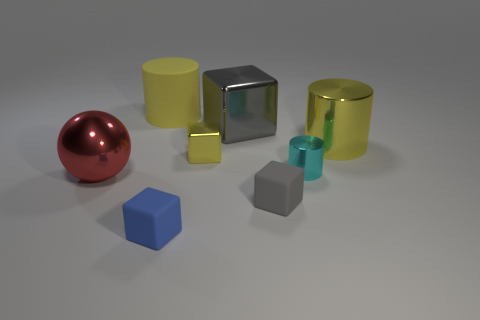Subtract 1 blocks. How many blocks are left? 3 Subtract all purple blocks. Subtract all gray balls. How many blocks are left? 4 Add 1 brown shiny cylinders. How many objects exist? 9 Subtract all spheres. How many objects are left? 7 Add 2 big yellow metallic cylinders. How many big yellow metallic cylinders are left? 3 Add 5 blue rubber things. How many blue rubber things exist? 6 Subtract 0 yellow spheres. How many objects are left? 8 Subtract all small blue cubes. Subtract all cyan metallic objects. How many objects are left? 6 